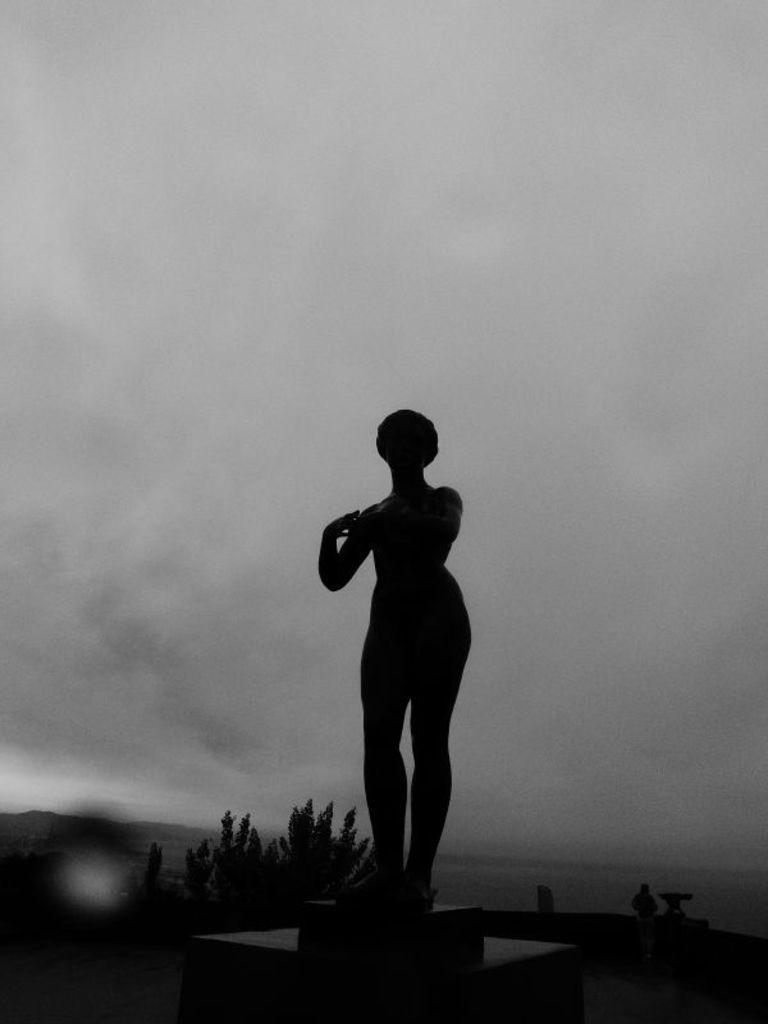What is the main subject in the foreground of the image? There is a sculpture in the foreground of the image. What is the color scheme of the image? The image is in black and white. What type of vegetation can be seen in the background of the image? There appears to be a plant in the background of the image. What is visible in the sky at the top of the image? There is a cloud visible at the top of the image. What color crayon is being used to draw the apple in the image? There is no crayon or apple present in the image; it features a sculpture and a plant. 